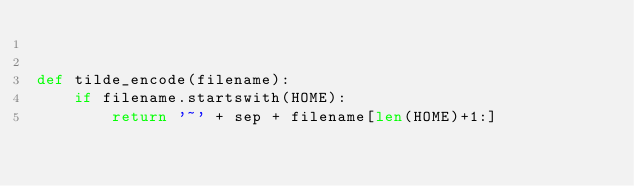<code> <loc_0><loc_0><loc_500><loc_500><_Python_>

def tilde_encode(filename):
    if filename.startswith(HOME):
        return '~' + sep + filename[len(HOME)+1:]

</code> 